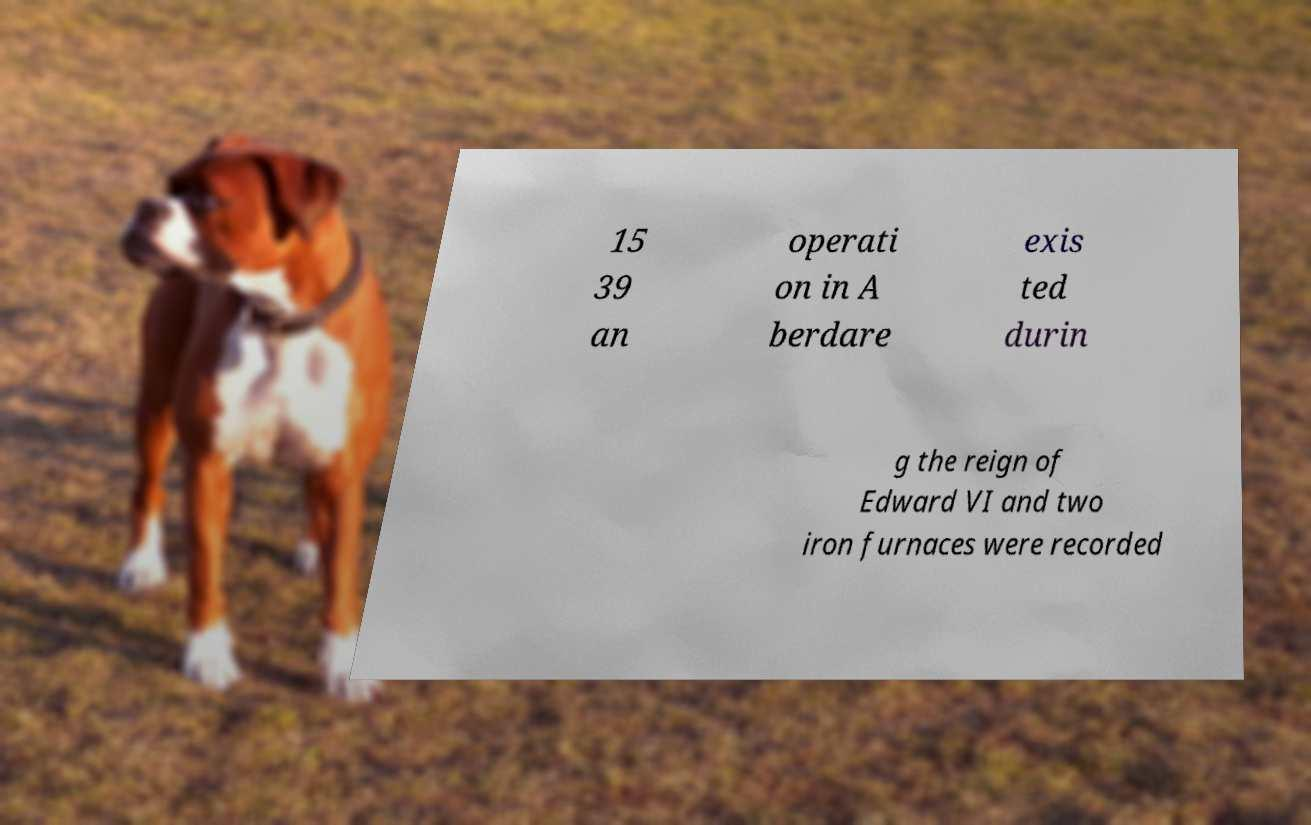Can you accurately transcribe the text from the provided image for me? 15 39 an operati on in A berdare exis ted durin g the reign of Edward VI and two iron furnaces were recorded 